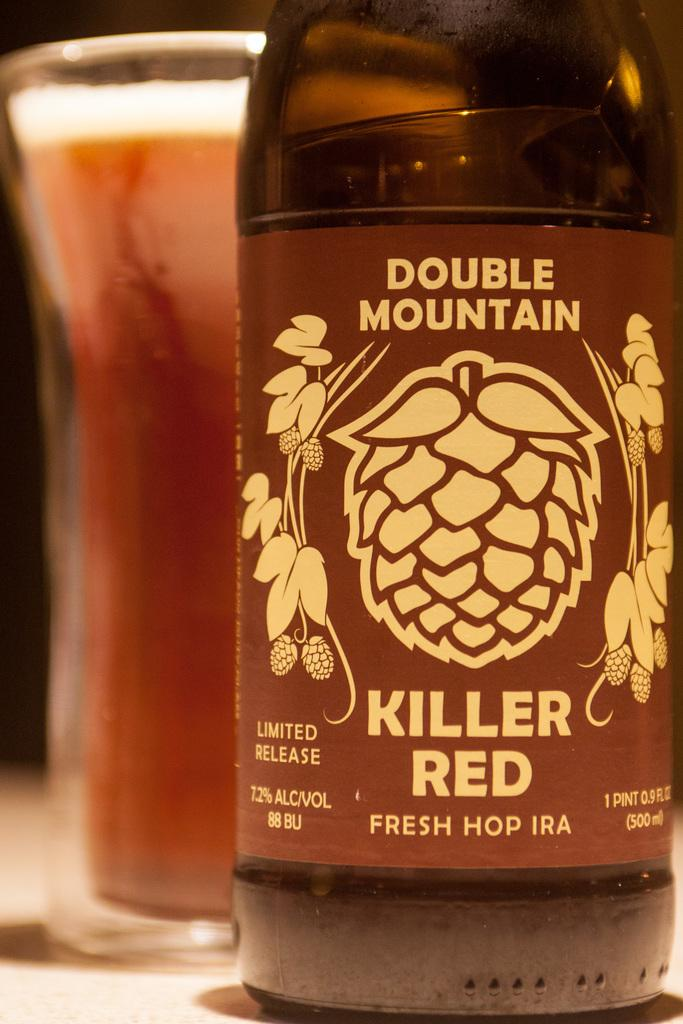<image>
Write a terse but informative summary of the picture. double mountain brand makes a Killer Red IPA 